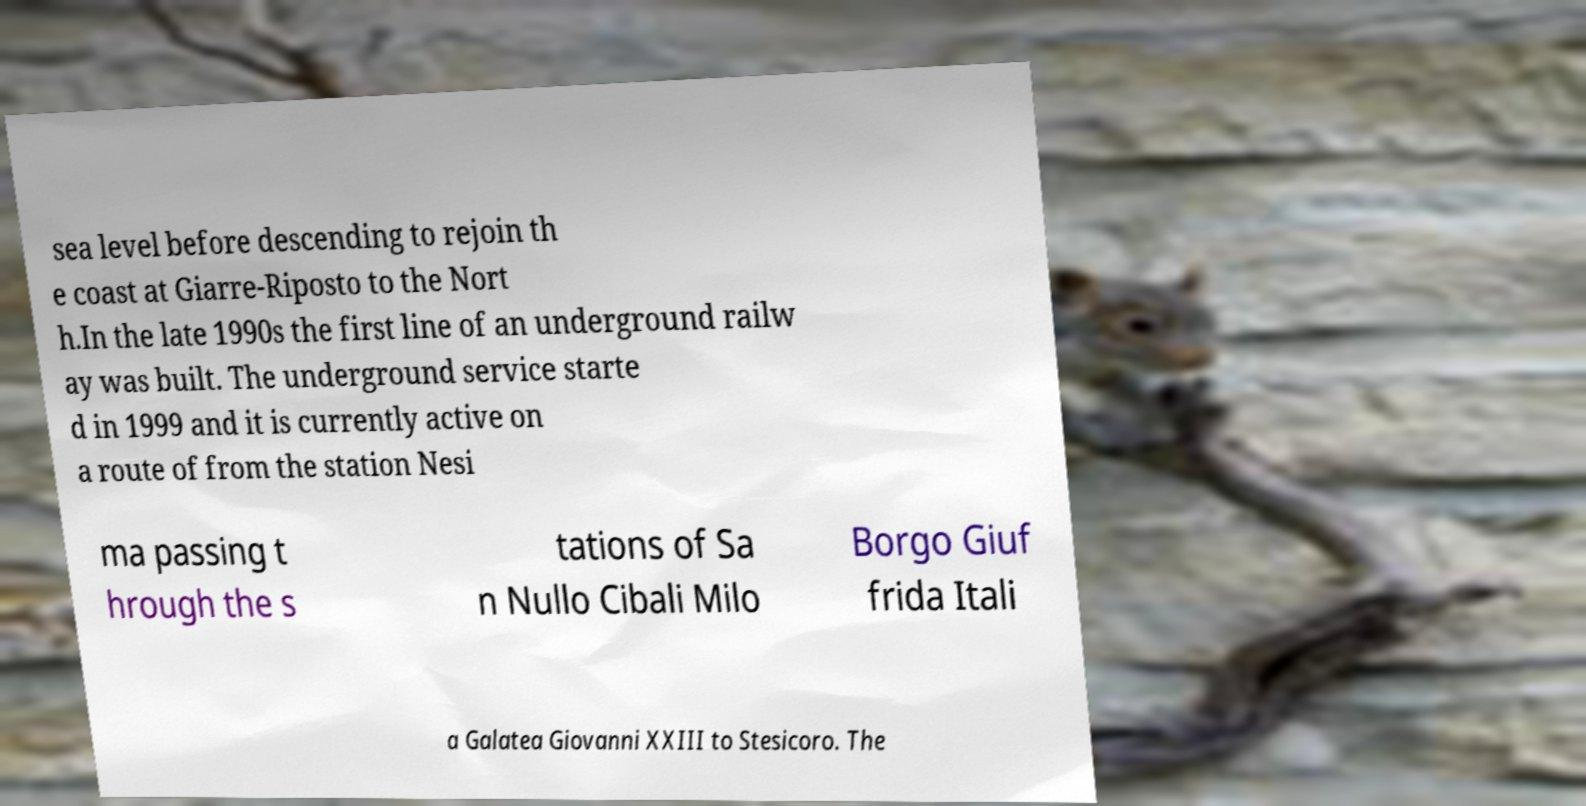Could you extract and type out the text from this image? sea level before descending to rejoin th e coast at Giarre-Riposto to the Nort h.In the late 1990s the first line of an underground railw ay was built. The underground service starte d in 1999 and it is currently active on a route of from the station Nesi ma passing t hrough the s tations of Sa n Nullo Cibali Milo Borgo Giuf frida Itali a Galatea Giovanni XXIII to Stesicoro. The 